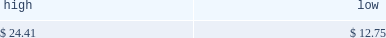Table of contents part ii price range our common stock commenced trading on the nasdaq national market under the symbol 201cmktx 201d on november 5 , 2004 .
Prior to that date , there was no public market for our common stock .
On november 4 , 2004 , the registration statement relating to our initial public offering was declared effective by the sec .
The high and low bid information for our common stock , as reported by nasdaq , was as follows : on march 28 , 2005 , the last reported closing price of our common stock on the nasdaq national market was $ 10.26 .
Holders there were approximately 188 holders of record of our common stock as of march 28 , 2005 .
Dividend policy we have not declared or paid any cash dividends on our capital stock since our inception .
We intend to retain future earnings to finance the operation and expansion of our business and do not anticipate paying any cash dividends in the foreseeable future .
In the event we decide to declare dividends on our common stock in the future , such declaration will be subject to the discretion of our board of directors .
Our board may take into account such matters as general business conditions , our financial results , capital requirements , contractual , legal , and regulatory restrictions on the payment of dividends by us to our stockholders or by our subsidiaries to us and any such other factors as our board may deem relevant .
Use of proceeds on november 4 , 2004 , the registration statement relating to our initial public offering ( no .
333-112718 ) was declared effective .
We received net proceeds from the sale of the shares of our common stock in the offering of $ 53.9 million , at an initial public offering price of $ 11.00 per share , after deducting underwriting discounts and commissions and estimated offering expenses .
Additionally , prior to the closing of the initial public offering , all outstanding shares of convertible preferred stock were converted into 14484493 shares of common stock and 4266310 shares of non-voting common stock .
The underwriters for our initial public offering were credit suisse first boston llc , j.p .
Morgan securities inc. , banc of america securities llc , bear , stearns & co .
Inc .
And ubs securities llc .
All of the underwriters are affiliates of some of our broker-dealer clients and affiliates of some our institutional investor clients .
In addition , affiliates of all the underwriters are stockholders of ours .
Except for salaries , and reimbursements for travel expenses and other out-of-pocket costs incurred in the ordinary course of business , none of the proceeds from the offering have been paid by us , directly or indirectly , to any of our directors or officers or any of their associates , or to any persons owning ten percent or more of our outstanding stock or to any of our affiliates .
As of december 31 , 2004 , we have not used any of the net proceeds from the initial public offering for product development costs , sales and marketing activities and working capital .
We have invested the proceeds from the offering in cash and cash equivalents and short-term marketable securities pending their use for these or other purposes .
Item 5 .
Market for registrant 2019s common equity , related stockholder matters and issuer purchases of equity securities november 5 , 2004 december 31 , 2004 .

What was the market cap of common stock as of march 28 , 2005? 
Computations: (10.26 * 188)
Answer: 1928.88. 